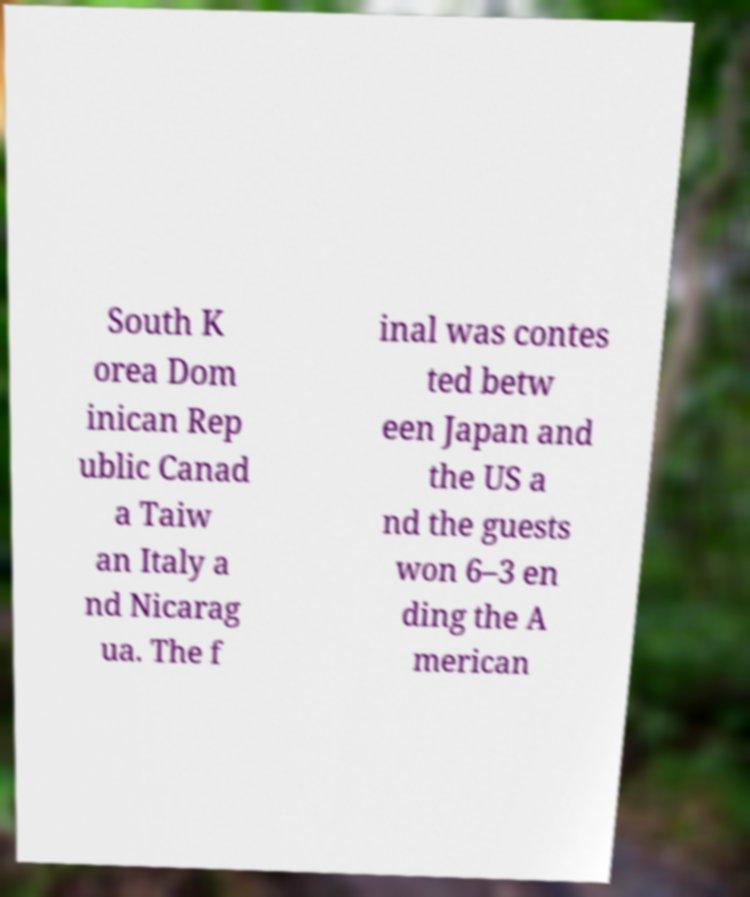For documentation purposes, I need the text within this image transcribed. Could you provide that? South K orea Dom inican Rep ublic Canad a Taiw an Italy a nd Nicarag ua. The f inal was contes ted betw een Japan and the US a nd the guests won 6–3 en ding the A merican 